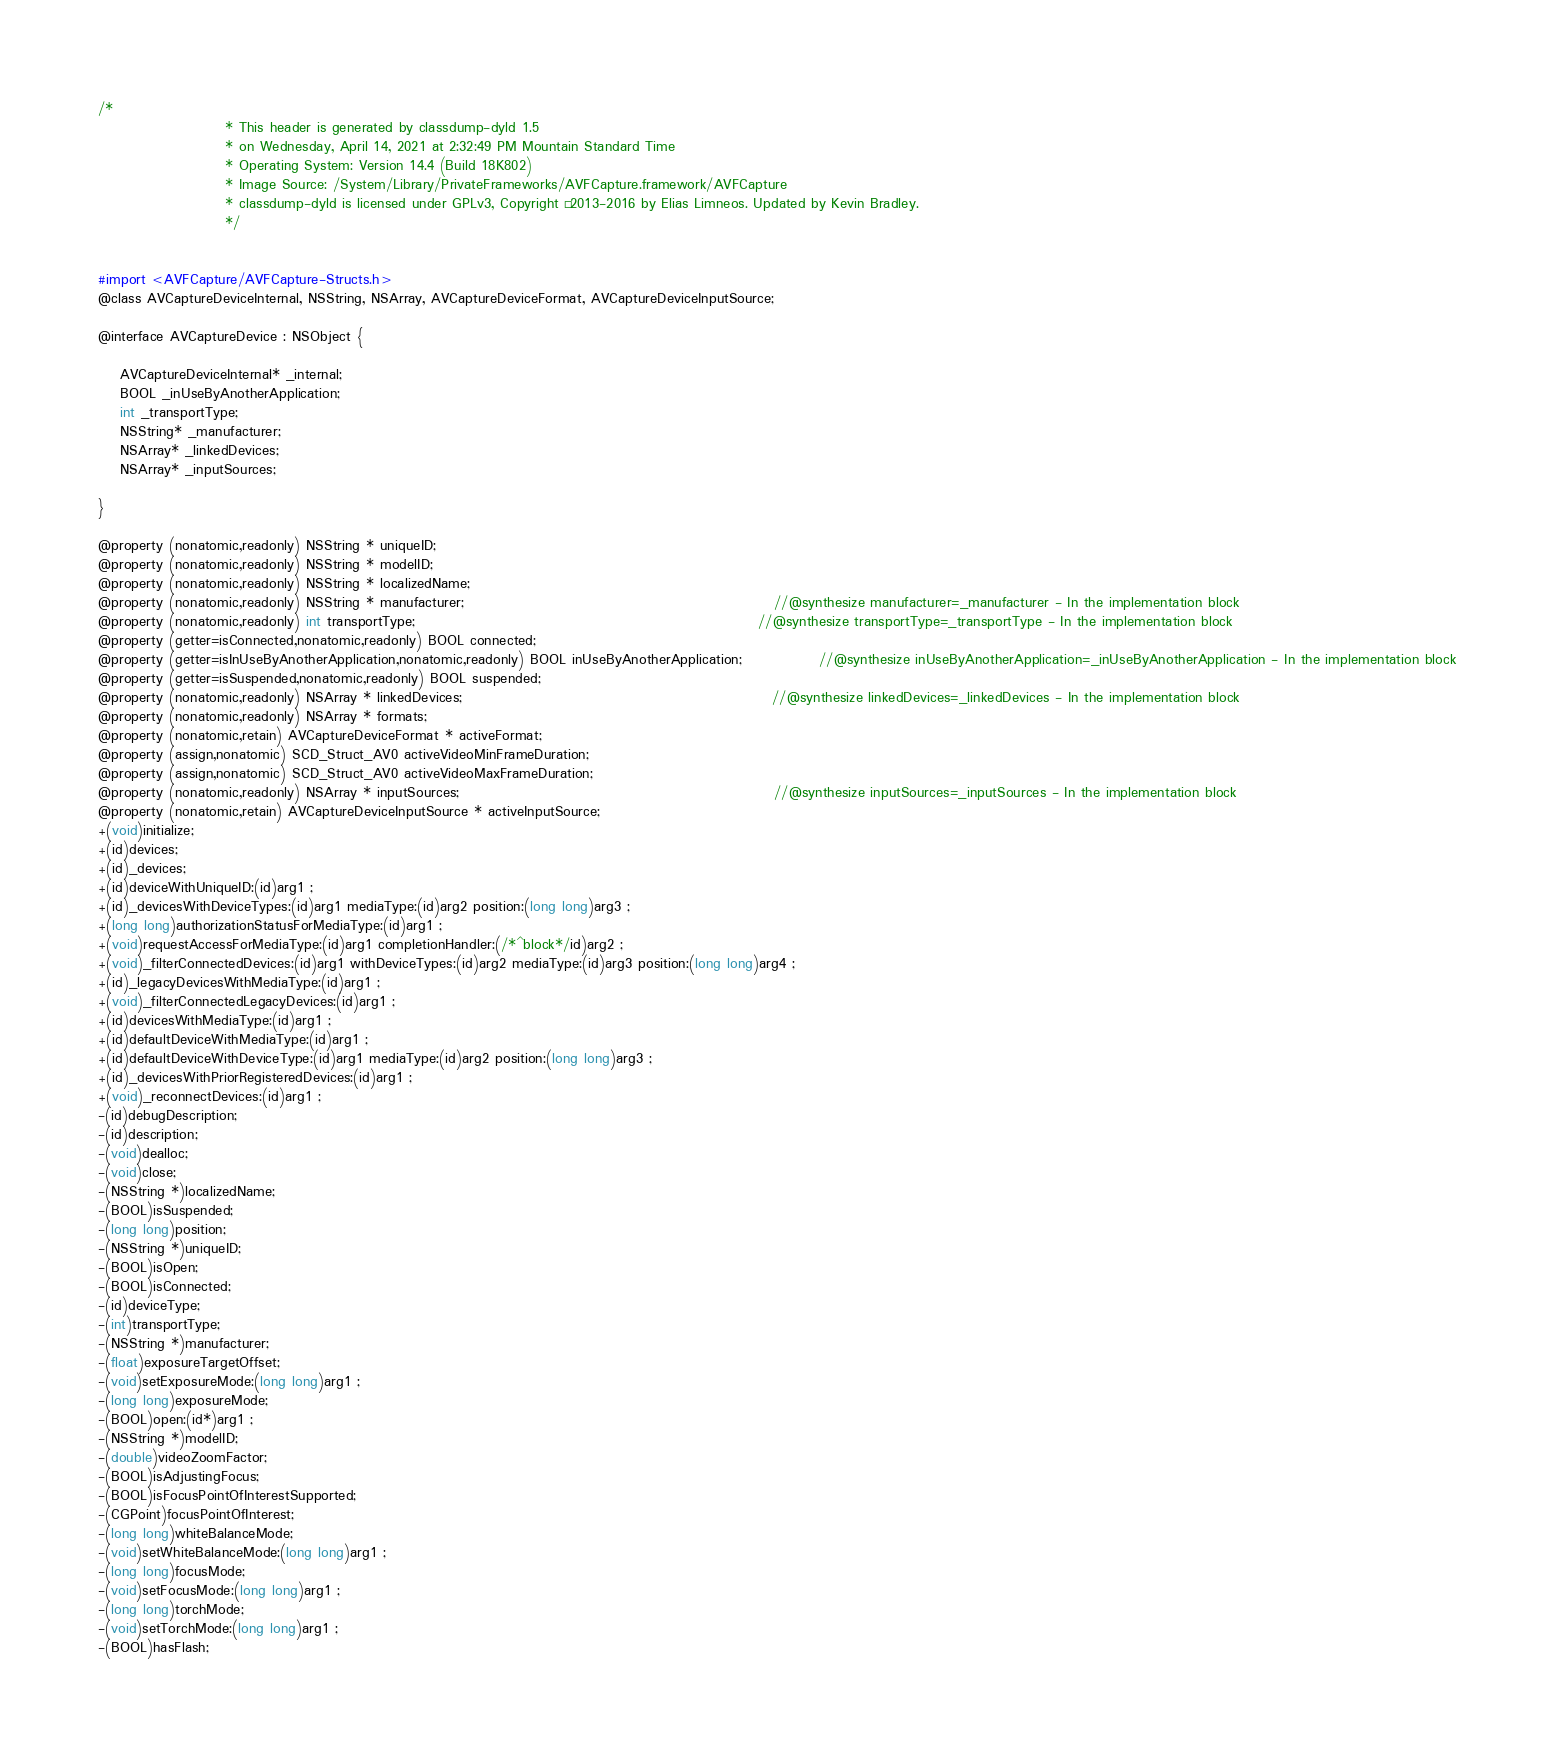<code> <loc_0><loc_0><loc_500><loc_500><_C_>/*
                       * This header is generated by classdump-dyld 1.5
                       * on Wednesday, April 14, 2021 at 2:32:49 PM Mountain Standard Time
                       * Operating System: Version 14.4 (Build 18K802)
                       * Image Source: /System/Library/PrivateFrameworks/AVFCapture.framework/AVFCapture
                       * classdump-dyld is licensed under GPLv3, Copyright © 2013-2016 by Elias Limneos. Updated by Kevin Bradley.
                       */


#import <AVFCapture/AVFCapture-Structs.h>
@class AVCaptureDeviceInternal, NSString, NSArray, AVCaptureDeviceFormat, AVCaptureDeviceInputSource;

@interface AVCaptureDevice : NSObject {

	AVCaptureDeviceInternal* _internal;
	BOOL _inUseByAnotherApplication;
	int _transportType;
	NSString* _manufacturer;
	NSArray* _linkedDevices;
	NSArray* _inputSources;

}

@property (nonatomic,readonly) NSString * uniqueID; 
@property (nonatomic,readonly) NSString * modelID; 
@property (nonatomic,readonly) NSString * localizedName; 
@property (nonatomic,readonly) NSString * manufacturer;                                                        //@synthesize manufacturer=_manufacturer - In the implementation block
@property (nonatomic,readonly) int transportType;                                                              //@synthesize transportType=_transportType - In the implementation block
@property (getter=isConnected,nonatomic,readonly) BOOL connected; 
@property (getter=isInUseByAnotherApplication,nonatomic,readonly) BOOL inUseByAnotherApplication;              //@synthesize inUseByAnotherApplication=_inUseByAnotherApplication - In the implementation block
@property (getter=isSuspended,nonatomic,readonly) BOOL suspended; 
@property (nonatomic,readonly) NSArray * linkedDevices;                                                        //@synthesize linkedDevices=_linkedDevices - In the implementation block
@property (nonatomic,readonly) NSArray * formats; 
@property (nonatomic,retain) AVCaptureDeviceFormat * activeFormat; 
@property (assign,nonatomic) SCD_Struct_AV0 activeVideoMinFrameDuration; 
@property (assign,nonatomic) SCD_Struct_AV0 activeVideoMaxFrameDuration; 
@property (nonatomic,readonly) NSArray * inputSources;                                                         //@synthesize inputSources=_inputSources - In the implementation block
@property (nonatomic,retain) AVCaptureDeviceInputSource * activeInputSource; 
+(void)initialize;
+(id)devices;
+(id)_devices;
+(id)deviceWithUniqueID:(id)arg1 ;
+(id)_devicesWithDeviceTypes:(id)arg1 mediaType:(id)arg2 position:(long long)arg3 ;
+(long long)authorizationStatusForMediaType:(id)arg1 ;
+(void)requestAccessForMediaType:(id)arg1 completionHandler:(/*^block*/id)arg2 ;
+(void)_filterConnectedDevices:(id)arg1 withDeviceTypes:(id)arg2 mediaType:(id)arg3 position:(long long)arg4 ;
+(id)_legacyDevicesWithMediaType:(id)arg1 ;
+(void)_filterConnectedLegacyDevices:(id)arg1 ;
+(id)devicesWithMediaType:(id)arg1 ;
+(id)defaultDeviceWithMediaType:(id)arg1 ;
+(id)defaultDeviceWithDeviceType:(id)arg1 mediaType:(id)arg2 position:(long long)arg3 ;
+(id)_devicesWithPriorRegisteredDevices:(id)arg1 ;
+(void)_reconnectDevices:(id)arg1 ;
-(id)debugDescription;
-(id)description;
-(void)dealloc;
-(void)close;
-(NSString *)localizedName;
-(BOOL)isSuspended;
-(long long)position;
-(NSString *)uniqueID;
-(BOOL)isOpen;
-(BOOL)isConnected;
-(id)deviceType;
-(int)transportType;
-(NSString *)manufacturer;
-(float)exposureTargetOffset;
-(void)setExposureMode:(long long)arg1 ;
-(long long)exposureMode;
-(BOOL)open:(id*)arg1 ;
-(NSString *)modelID;
-(double)videoZoomFactor;
-(BOOL)isAdjustingFocus;
-(BOOL)isFocusPointOfInterestSupported;
-(CGPoint)focusPointOfInterest;
-(long long)whiteBalanceMode;
-(void)setWhiteBalanceMode:(long long)arg1 ;
-(long long)focusMode;
-(void)setFocusMode:(long long)arg1 ;
-(long long)torchMode;
-(void)setTorchMode:(long long)arg1 ;
-(BOOL)hasFlash;</code> 